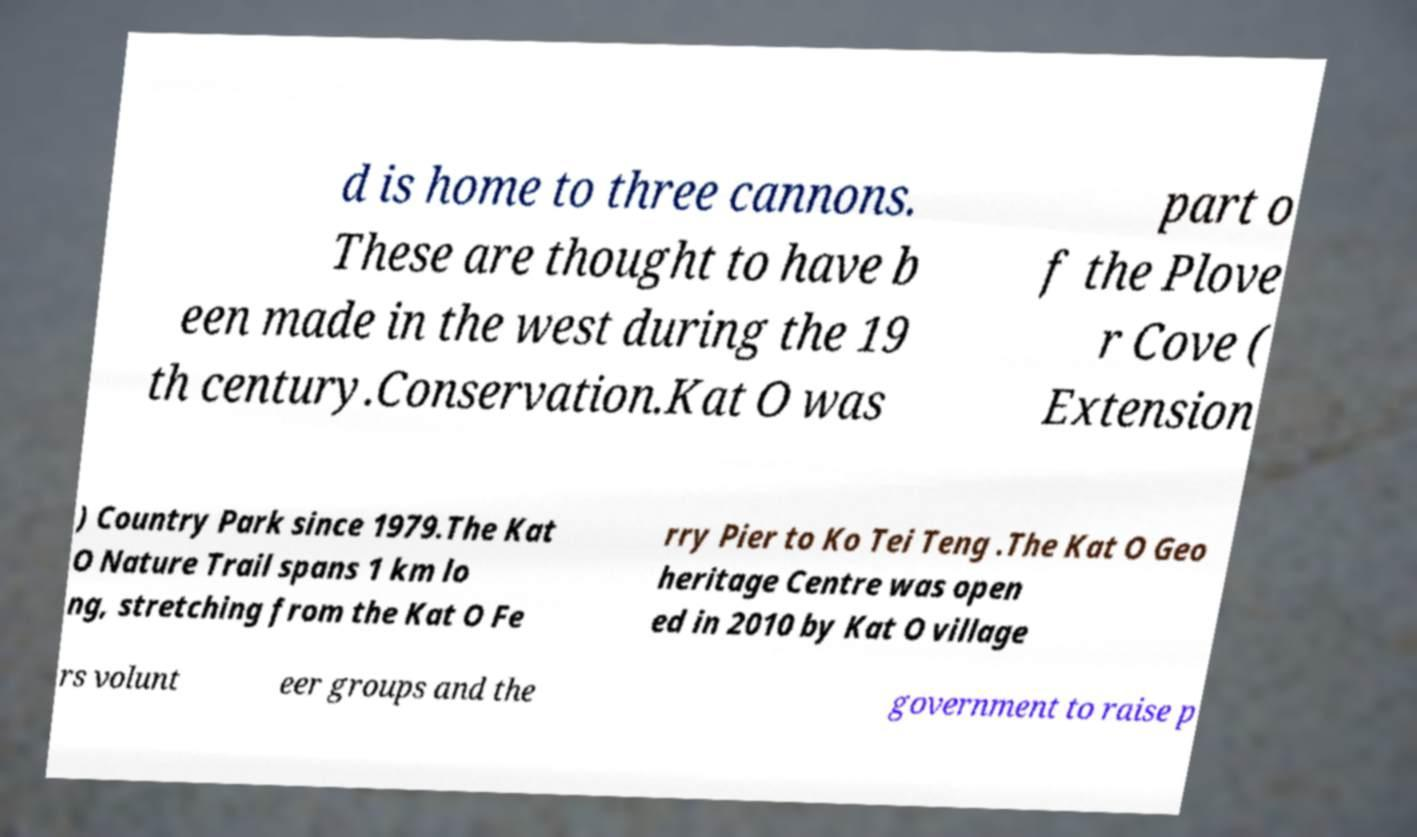Can you accurately transcribe the text from the provided image for me? d is home to three cannons. These are thought to have b een made in the west during the 19 th century.Conservation.Kat O was part o f the Plove r Cove ( Extension ) Country Park since 1979.The Kat O Nature Trail spans 1 km lo ng, stretching from the Kat O Fe rry Pier to Ko Tei Teng .The Kat O Geo heritage Centre was open ed in 2010 by Kat O village rs volunt eer groups and the government to raise p 